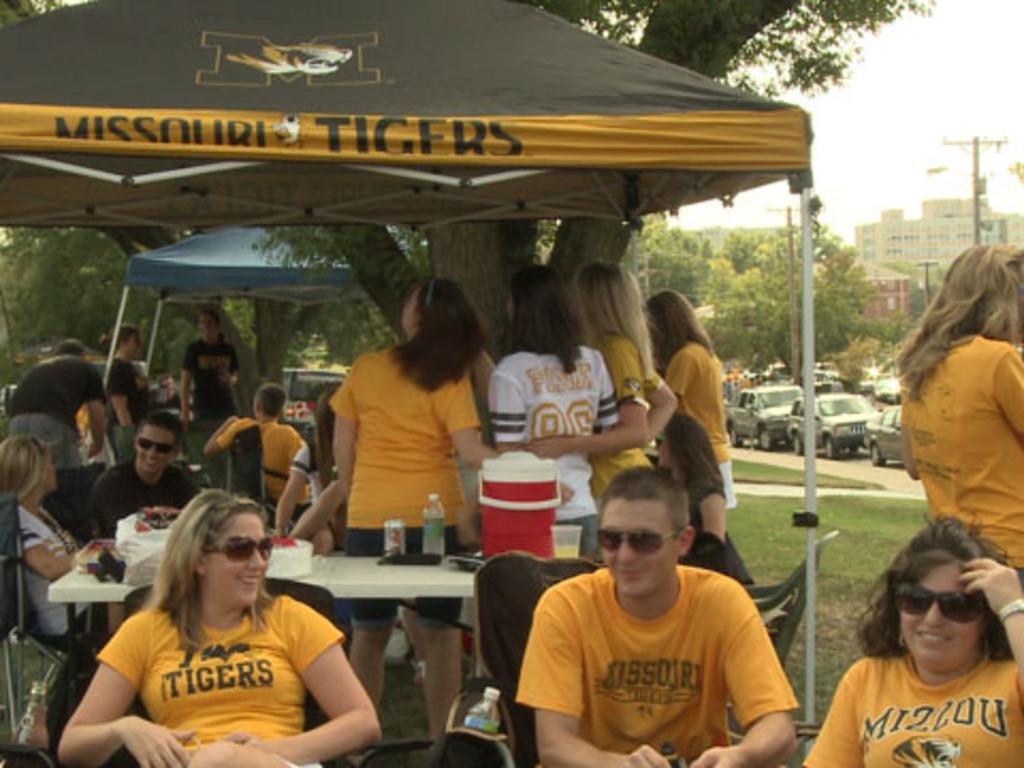How would you summarize this image in a sentence or two? In this image there are so many people sitting and standing under the tent beside them there is a tree and also there are so many cars riding on the road, also there are some buildings trees beside the road. 